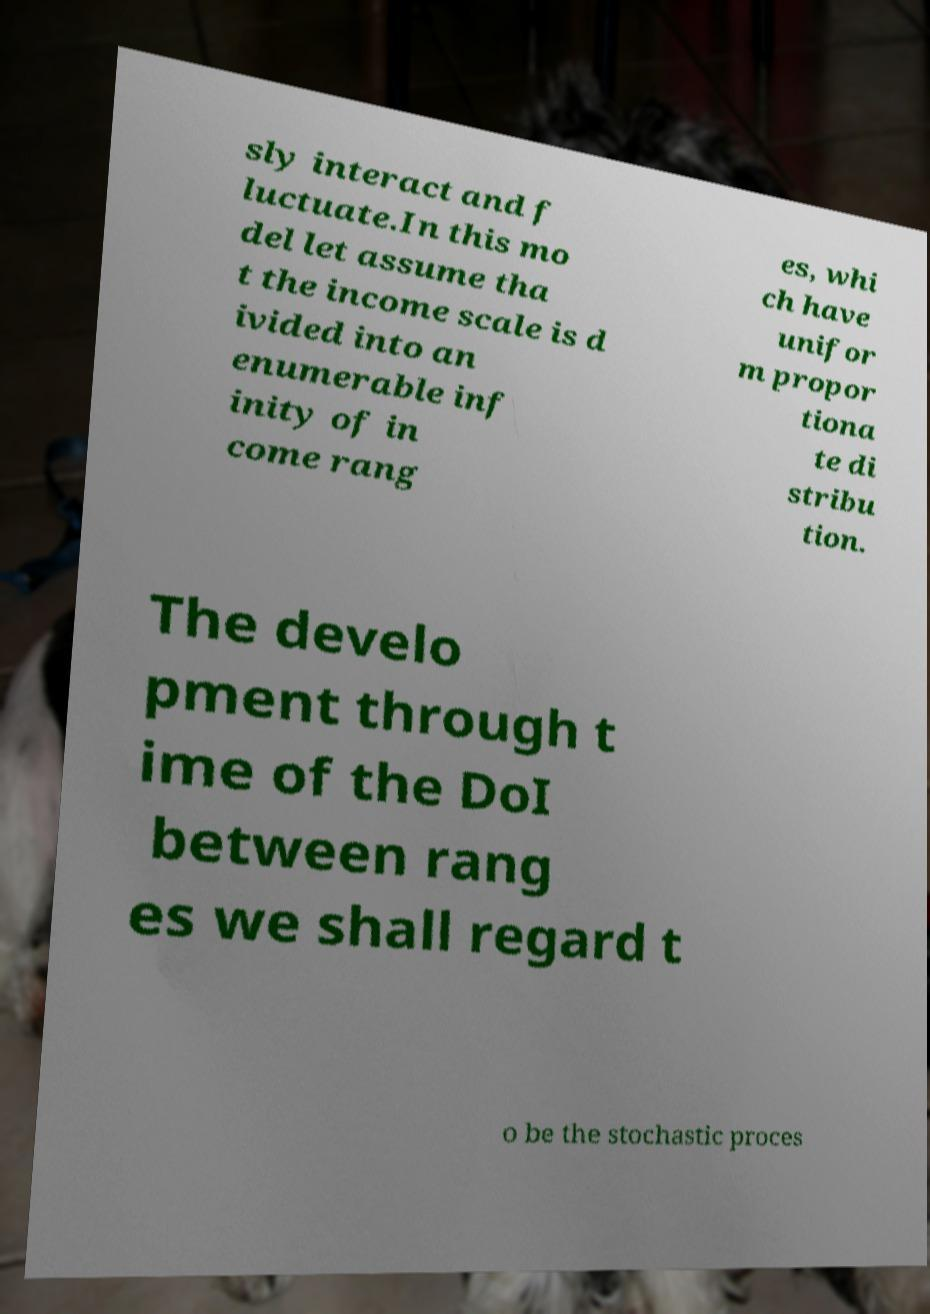Could you assist in decoding the text presented in this image and type it out clearly? sly interact and f luctuate.In this mo del let assume tha t the income scale is d ivided into an enumerable inf inity of in come rang es, whi ch have unifor m propor tiona te di stribu tion. The develo pment through t ime of the DoI between rang es we shall regard t o be the stochastic proces 